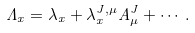Convert formula to latex. <formula><loc_0><loc_0><loc_500><loc_500>\Lambda _ { x } = \lambda _ { x } + \lambda ^ { J , \mu } _ { x } A ^ { J } _ { \mu } + \cdots \, .</formula> 